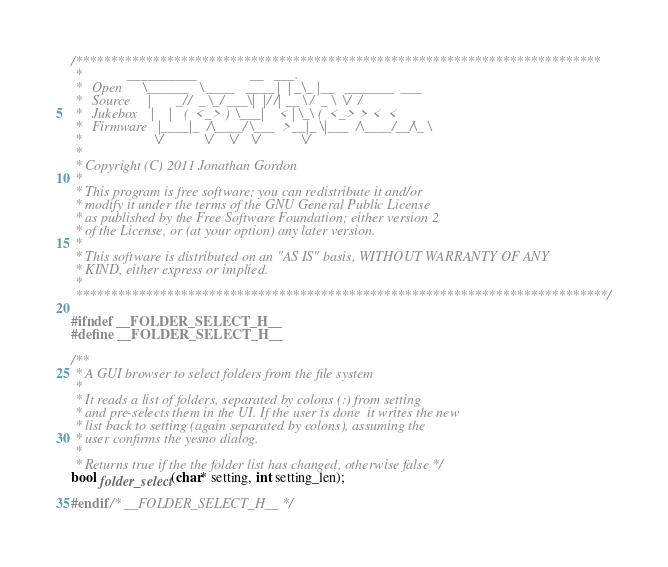Convert code to text. <code><loc_0><loc_0><loc_500><loc_500><_C_>/***************************************************************************
 *             __________               __   ___.
 *   Open      \______   \ ____   ____ |  | _\_ |__   _______  ___
 *   Source     |       _//  _ \_/ ___\|  |/ /| __ \ /  _ \  \/  /
 *   Jukebox    |    |   (  <_> )  \___|    < | \_\ (  <_> > <  <
 *   Firmware   |____|_  /\____/ \___  >__|_ \|___  /\____/__/\_ \
 *                     \/            \/     \/    \/            \/
 *
 * Copyright (C) 2011 Jonathan Gordon
 *
 * This program is free software; you can redistribute it and/or
 * modify it under the terms of the GNU General Public License
 * as published by the Free Software Foundation; either version 2
 * of the License, or (at your option) any later version.
 *
 * This software is distributed on an "AS IS" basis, WITHOUT WARRANTY OF ANY
 * KIND, either express or implied.
 *
 ****************************************************************************/

#ifndef __FOLDER_SELECT_H__
#define __FOLDER_SELECT_H__

/**
 * A GUI browser to select folders from the file system
 *
 * It reads a list of folders, separated by colons (:) from setting
 * and pre-selects them in the UI. If the user is done  it writes the new
 * list back to setting (again separated by colons), assuming the
 * user confirms the yesno dialog.
 *
 * Returns true if the the folder list has changed, otherwise false */
bool folder_select(char* setting, int setting_len);

#endif /* __FOLDER_SELECT_H__ */
</code> 